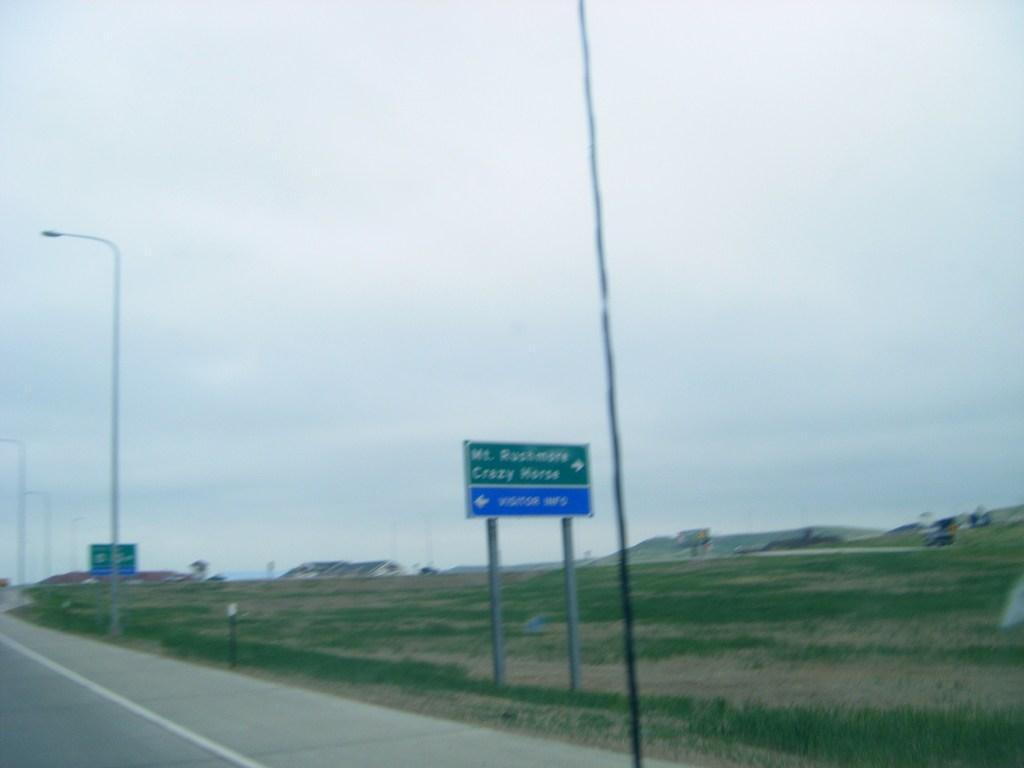How would you summarize this image in a sentence or two? In this picture I can see there is a road and there are few poles and direction boards. There is grass, mountains and the sky is clear. 